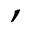<formula> <loc_0><loc_0><loc_500><loc_500>,</formula> 